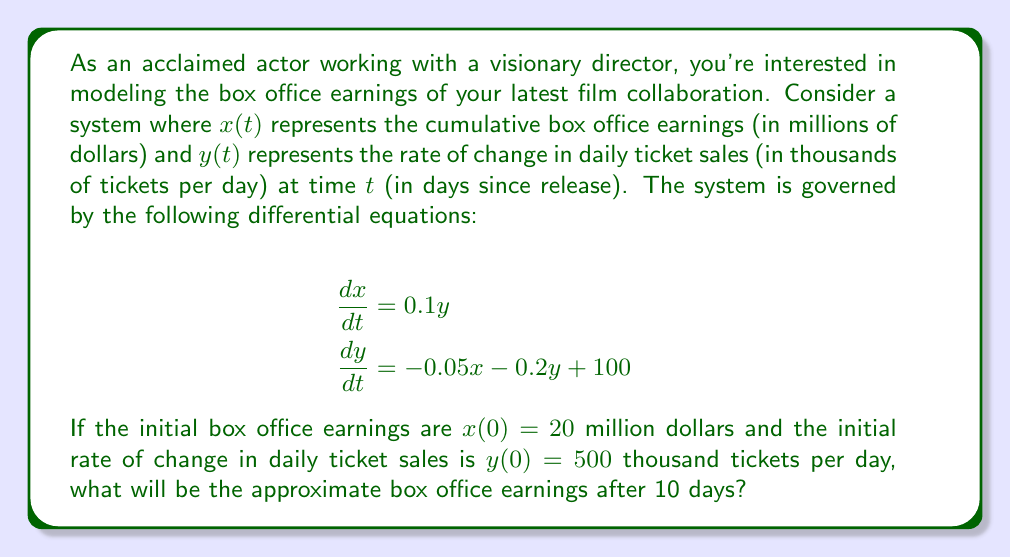Solve this math problem. To solve this problem, we need to use numerical methods to approximate the solution of the system of differential equations. We'll use the Euler method with a step size of 1 day.

Step 1: Set up the initial conditions and parameters
$x(0) = 20$, $y(0) = 500$, $t = 0$, $\Delta t = 1$, $n = 10$ (number of steps)

Step 2: Apply the Euler method iteratively
For $i = 1$ to $n$:
$x_{i+1} = x_i + \Delta t \cdot (0.1y_i)$
$y_{i+1} = y_i + \Delta t \cdot (-0.05x_i - 0.2y_i + 100)$

Step 3: Compute the values for each day
Day 0: $x_0 = 20$, $y_0 = 500$
Day 1: $x_1 = 20 + 1 \cdot (0.1 \cdot 500) = 70$
       $y_1 = 500 + 1 \cdot (-0.05 \cdot 20 - 0.2 \cdot 500 + 100) = 499$
Day 2: $x_2 = 70 + 1 \cdot (0.1 \cdot 499) = 119.9$
       $y_2 = 499 + 1 \cdot (-0.05 \cdot 70 - 0.2 \cdot 499 + 100) = 494.2$
...

Continuing this process for 10 days, we get:
Day 10: $x_{10} \approx 508.7$

Step 4: Round the result to the nearest million dollars
$508.7$ million dollars ≈ $509$ million dollars
Answer: $509$ million dollars 